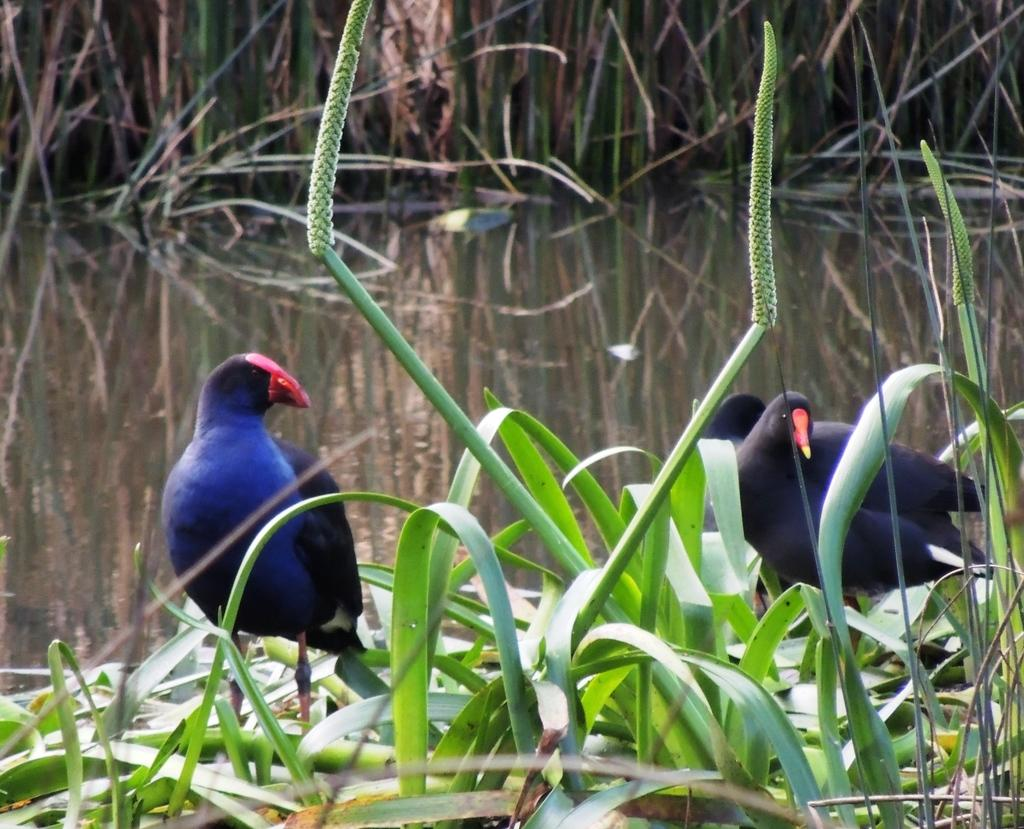How many birds are present in the image? There are three birds in the image. What is located at the bottom of the image? There are plants at the bottom of the image. What is in the middle of the image? There is water in the middle of the image. What type of vegetation can be seen in the background of the image? There appears to be grass in the background of the image. What type of stew is being prepared by the owl in the image? There is no owl or stew present in the image. 